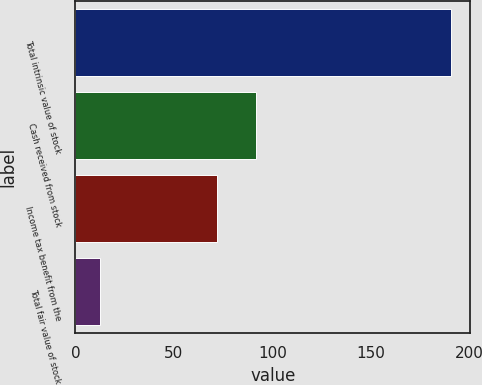Convert chart to OTSL. <chart><loc_0><loc_0><loc_500><loc_500><bar_chart><fcel>Total intrinsic value of stock<fcel>Cash received from stock<fcel>Income tax benefit from the<fcel>Total fair value of stock<nl><fcel>190.9<fcel>91.6<fcel>72.1<fcel>12.4<nl></chart> 